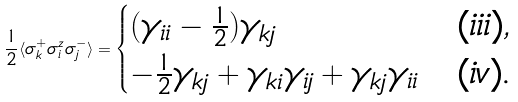<formula> <loc_0><loc_0><loc_500><loc_500>\frac { 1 } { 2 } \langle \sigma _ { k } ^ { + } \sigma _ { i } ^ { z } \sigma _ { j } ^ { - } \rangle = \begin{cases} ( \gamma _ { i i } - \frac { 1 } { 2 } ) \gamma _ { k j } & \text {($iii$)} , \\ - \frac { 1 } { 2 } \gamma _ { k j } + \gamma _ { k i } \gamma _ { i j } + \gamma _ { k j } \gamma _ { i i } & \text {($iv$).} \\ \end{cases}</formula> 